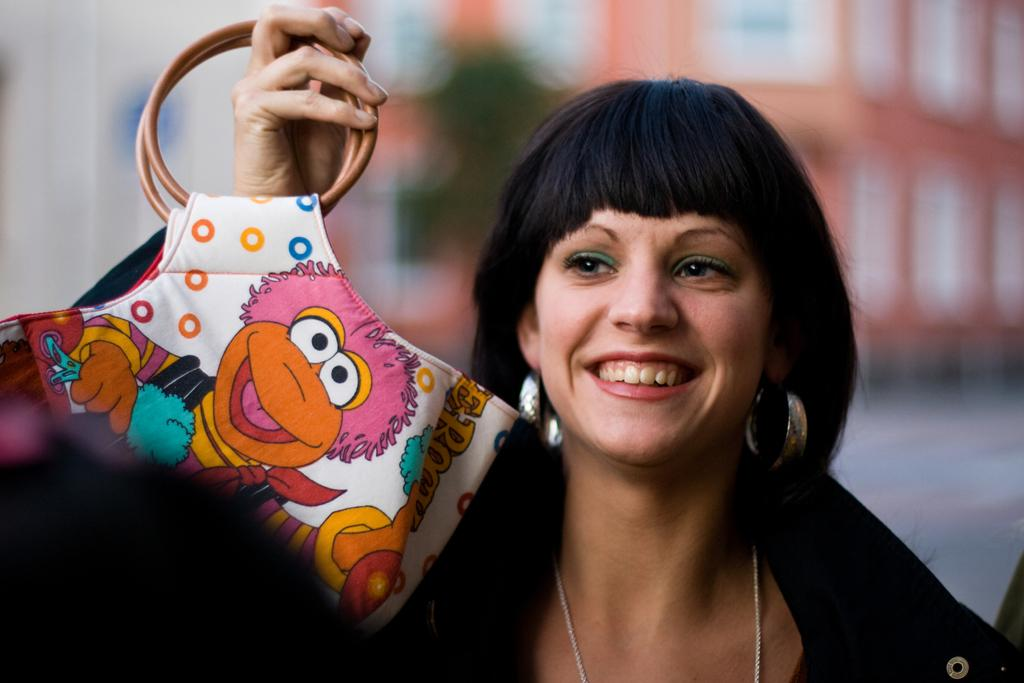Who is present in the image? There is a woman in the image. What is the woman doing in the image? The woman is laughing in the image. What object is the woman holding in her hand? The woman is holding a purse in her hand. What type of brick is the woman using to build a wall in the image? There is no brick or wall-building activity present in the image. 